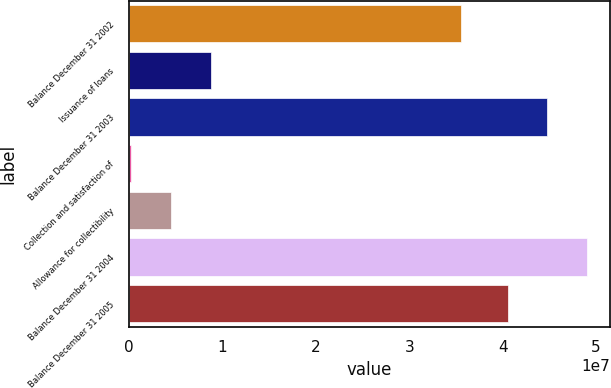Convert chart. <chart><loc_0><loc_0><loc_500><loc_500><bar_chart><fcel>Balance December 31 2002<fcel>Issuance of loans<fcel>Balance December 31 2003<fcel>Collection and satisfaction of<fcel>Allowance for collectibility<fcel>Balance December 31 2004<fcel>Balance December 31 2005<nl><fcel>3.5577e+07<fcel>8.7896e+06<fcel>4.47996e+07<fcel>223000<fcel>4.521e+06<fcel>4.90682e+07<fcel>4.0531e+07<nl></chart> 